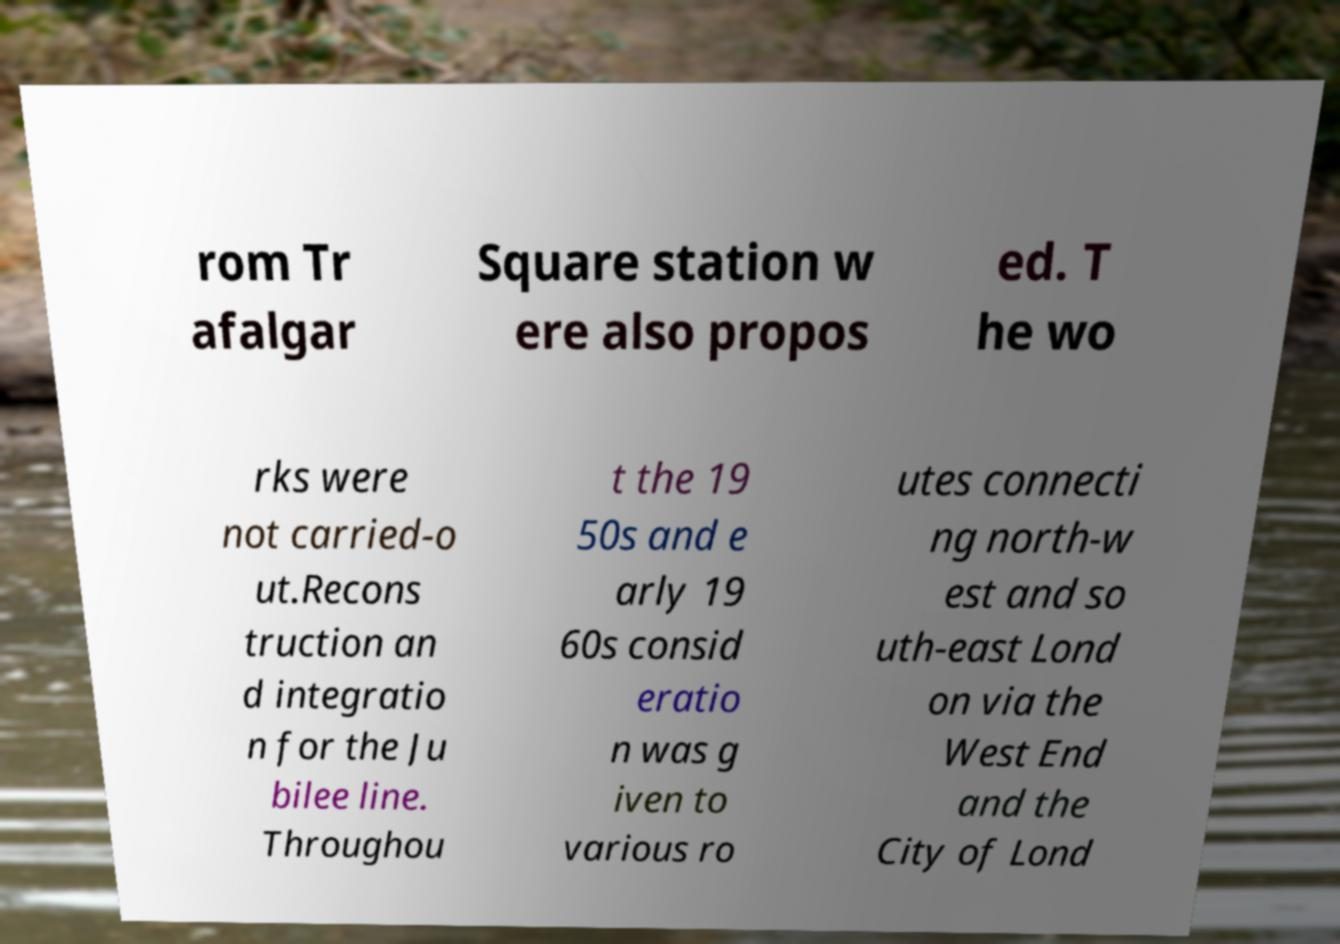Please identify and transcribe the text found in this image. rom Tr afalgar Square station w ere also propos ed. T he wo rks were not carried-o ut.Recons truction an d integratio n for the Ju bilee line. Throughou t the 19 50s and e arly 19 60s consid eratio n was g iven to various ro utes connecti ng north-w est and so uth-east Lond on via the West End and the City of Lond 